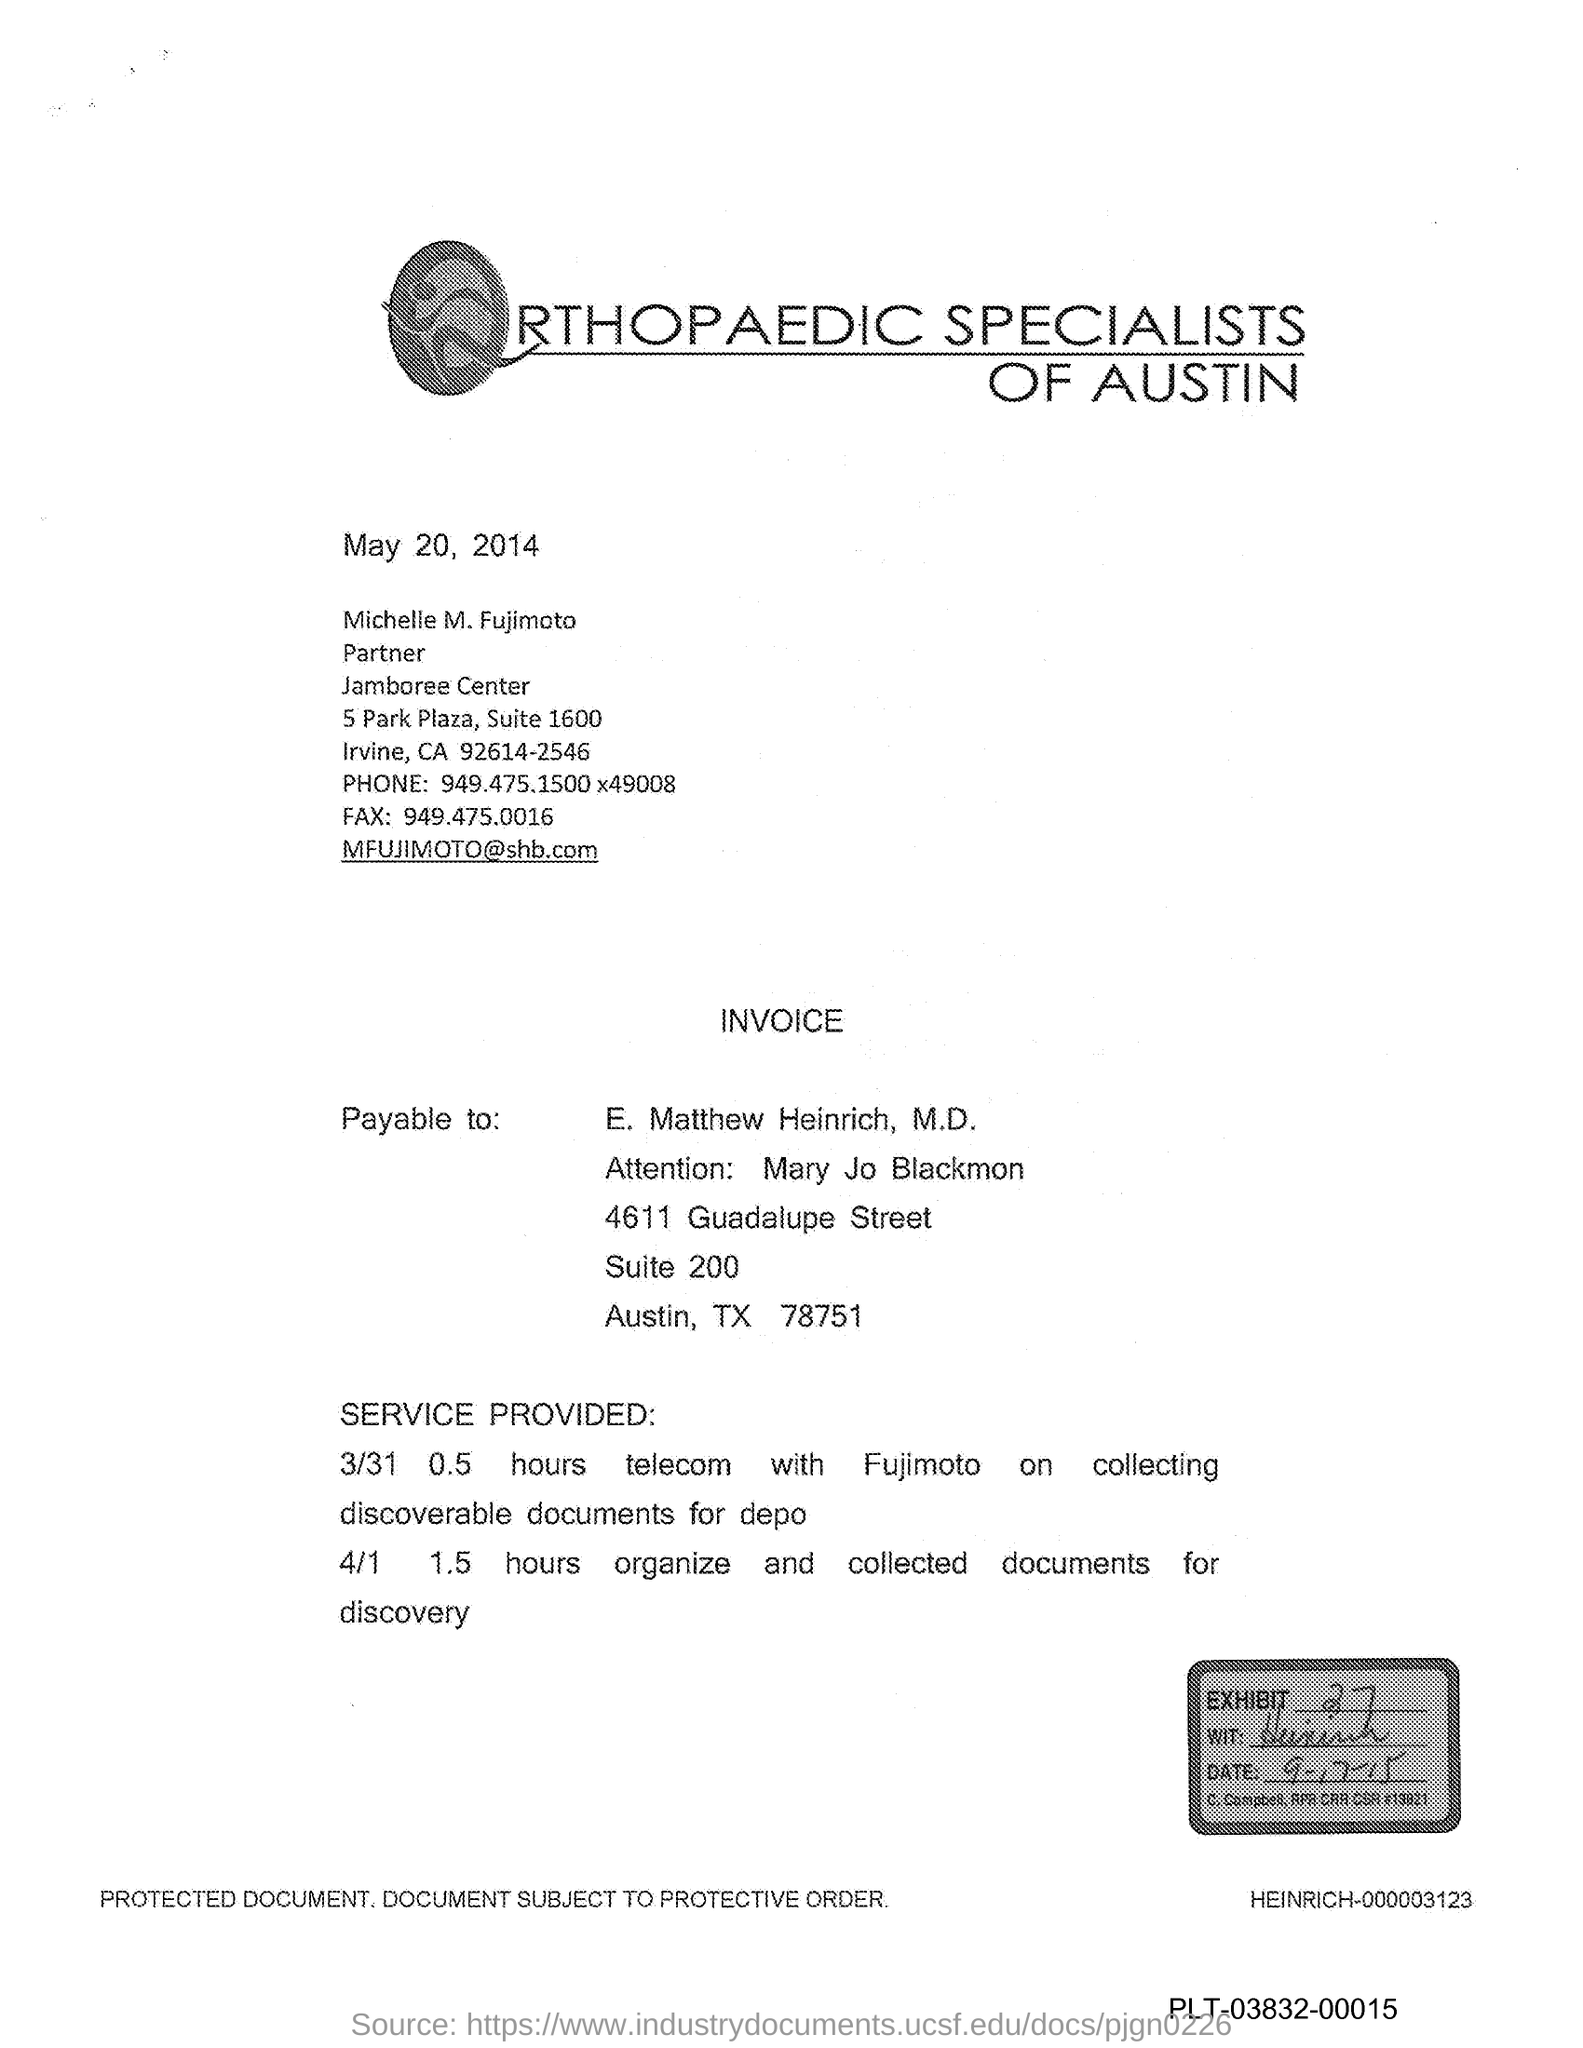What is the Exhibit number?
Offer a terse response. 27. What is the Fax number?
Offer a very short reply. 949.475.0016. 